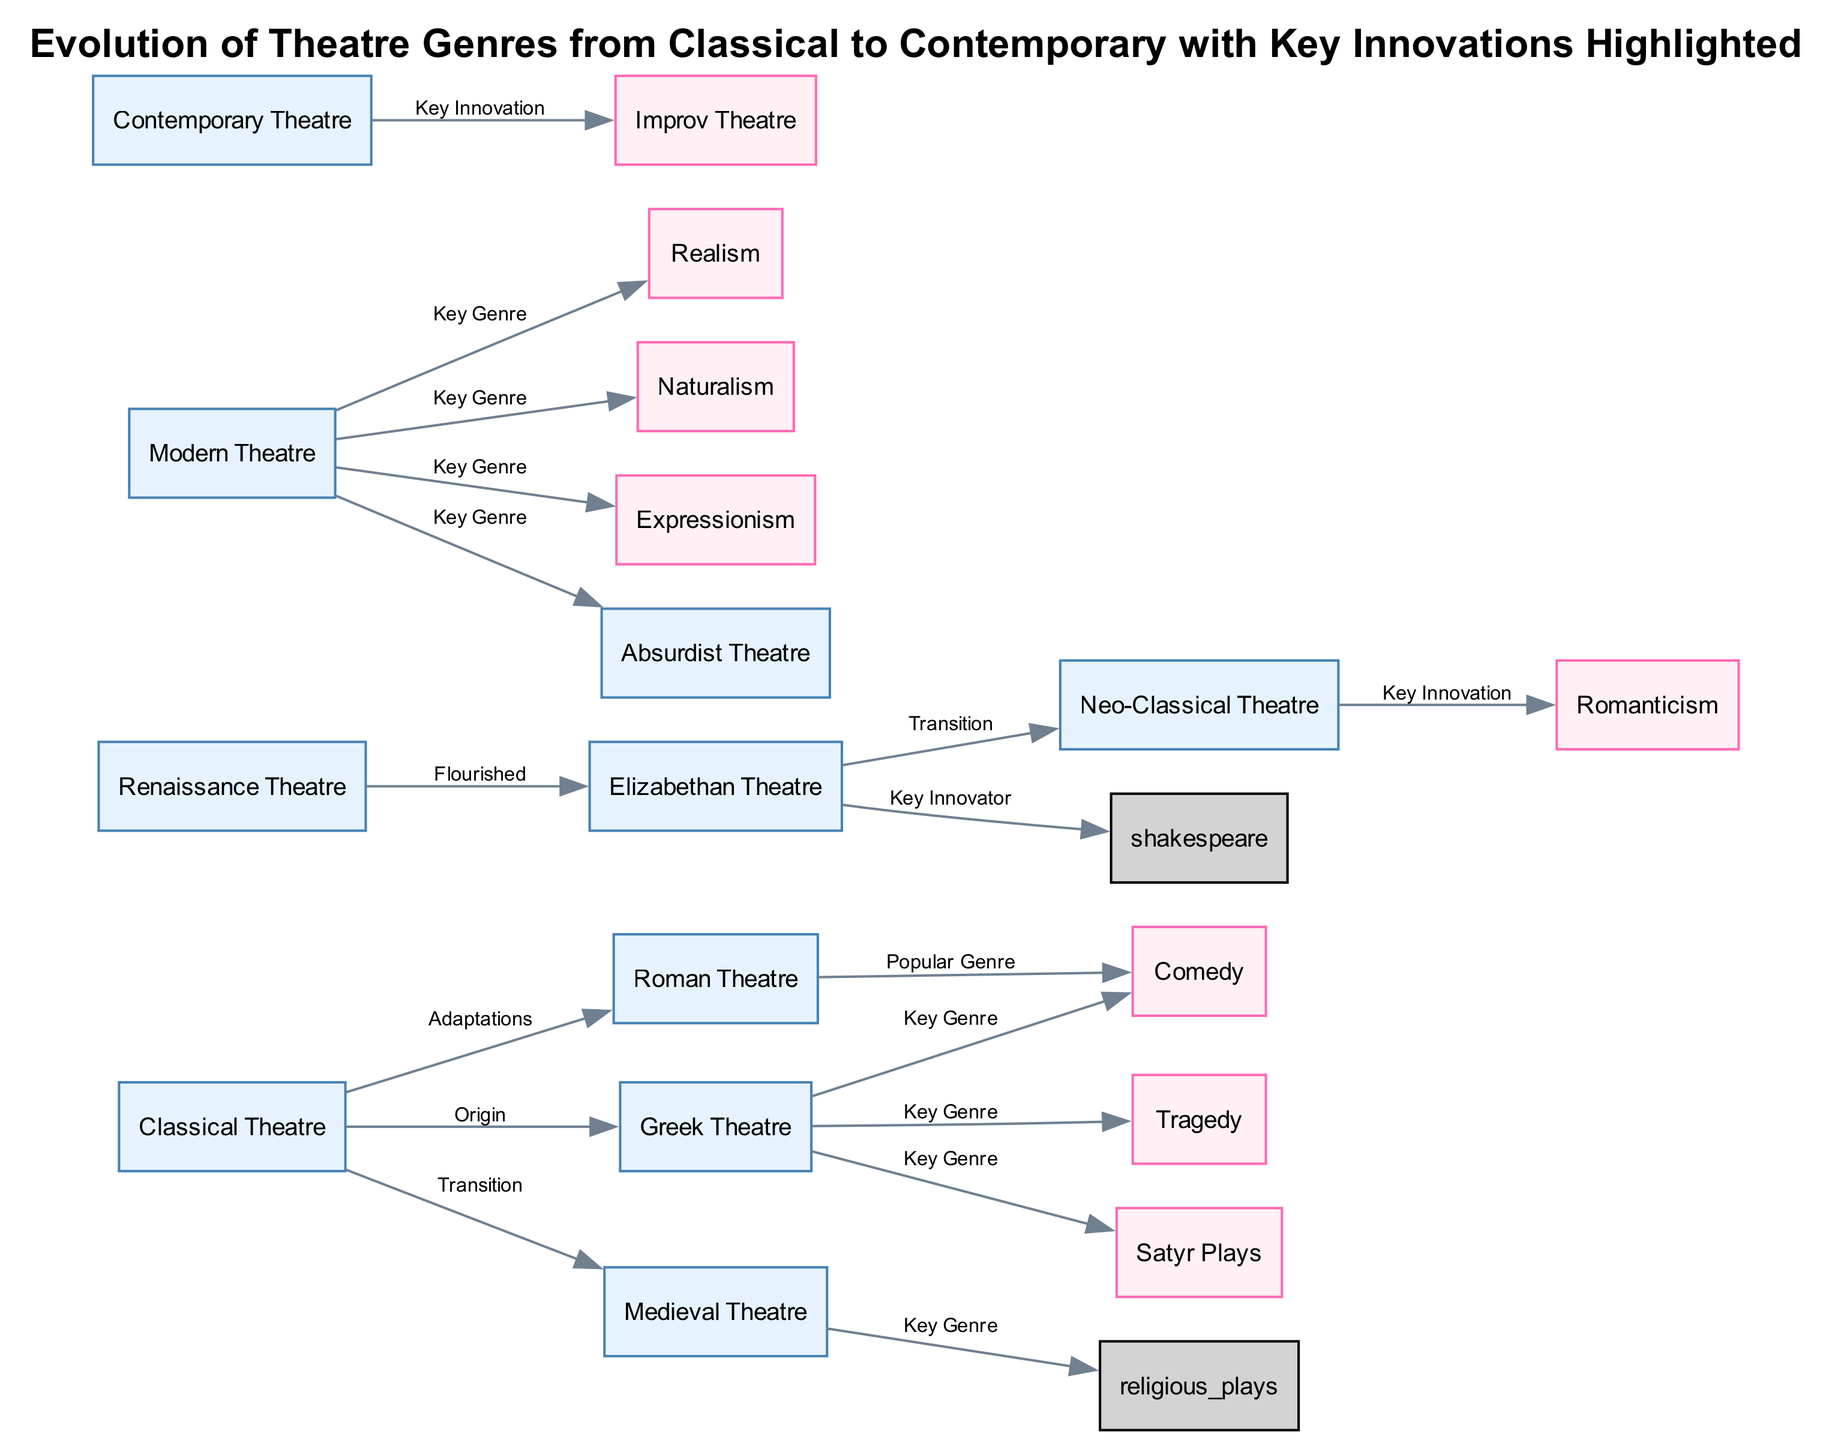What is the first genre highlighted as a key genre in Greek theatre? According to the diagram, the first genre associated with Greek theatre is 'tragedy'. This can be found directly connected to the Greek theatre node as a key genre.
Answer: tragedy How many key innovations are highlighted from modern theatre? The diagram shows four key genres associated with modern theatre (realism, naturalism, expressionism, and absurdist theatre). Counting these leads to the conclusion of four innovations.
Answer: 4 What genre transitioned from the Elizabethan theatre? The diagram indicates that 'neo-classical theatre' transitioned from Elizabethan theatre as represented by the edge connecting the two nodes labelled 'Transition'.
Answer: neo-classical theatre Which theatre genre is identified as a key innovation in contemporary theatre? The diagram specifies 'improv' as the key innovation linked to contemporary theatre, shown as a direct connection from the contemporary theatre node.
Answer: improv What are the three key genres branching from Greek theatre? The diagram illustrates that 'tragedy', 'comedy', and 'satyr plays' all branch from the Greek theatre node. This means these three genres are the key genres associated with it.
Answer: tragedy, comedy, satyr plays Which theatre genre is indicated as the popular genre in Roman theatre? The diagram connects Roman theatre to 'comedy' as its popular genre, shown on the edge labelled 'Popular Genre'. This is the only direct association of this type listed in the context of Roman theatre.
Answer: comedy What genre does modern theatre emphasize realism in? The direct connection from the modern theatre node to the realism node indicates that realism is emphasized in modern theatre as a significant genre. Hence, realism directly represents this emphasis.
Answer: realism How many genres are directly linked to classical theatre? The diagram shows five edges connecting to classical theatre, leading to genres such as Greek theatre, Roman theatre, medieval theatre, tragedy, and comedy, indicating a strong relationship with multiple genres.
Answer: 5 